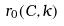Convert formula to latex. <formula><loc_0><loc_0><loc_500><loc_500>r _ { 0 } ( C , k )</formula> 